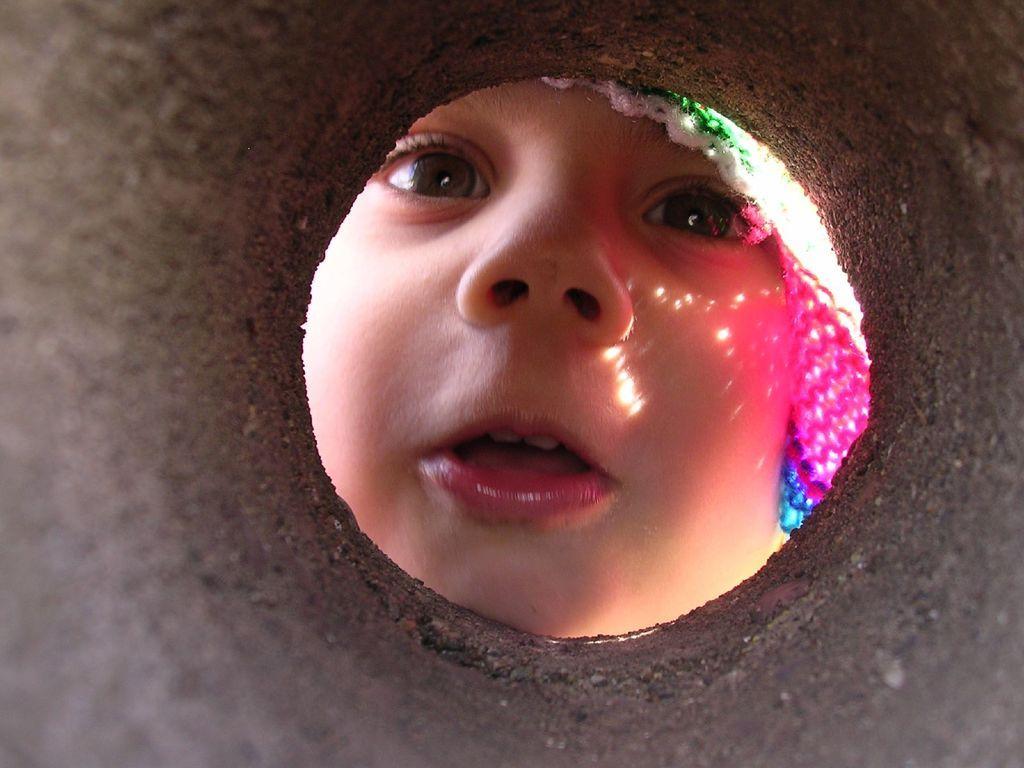Please provide a concise description of this image. In this image we can see a kid through the hole. 